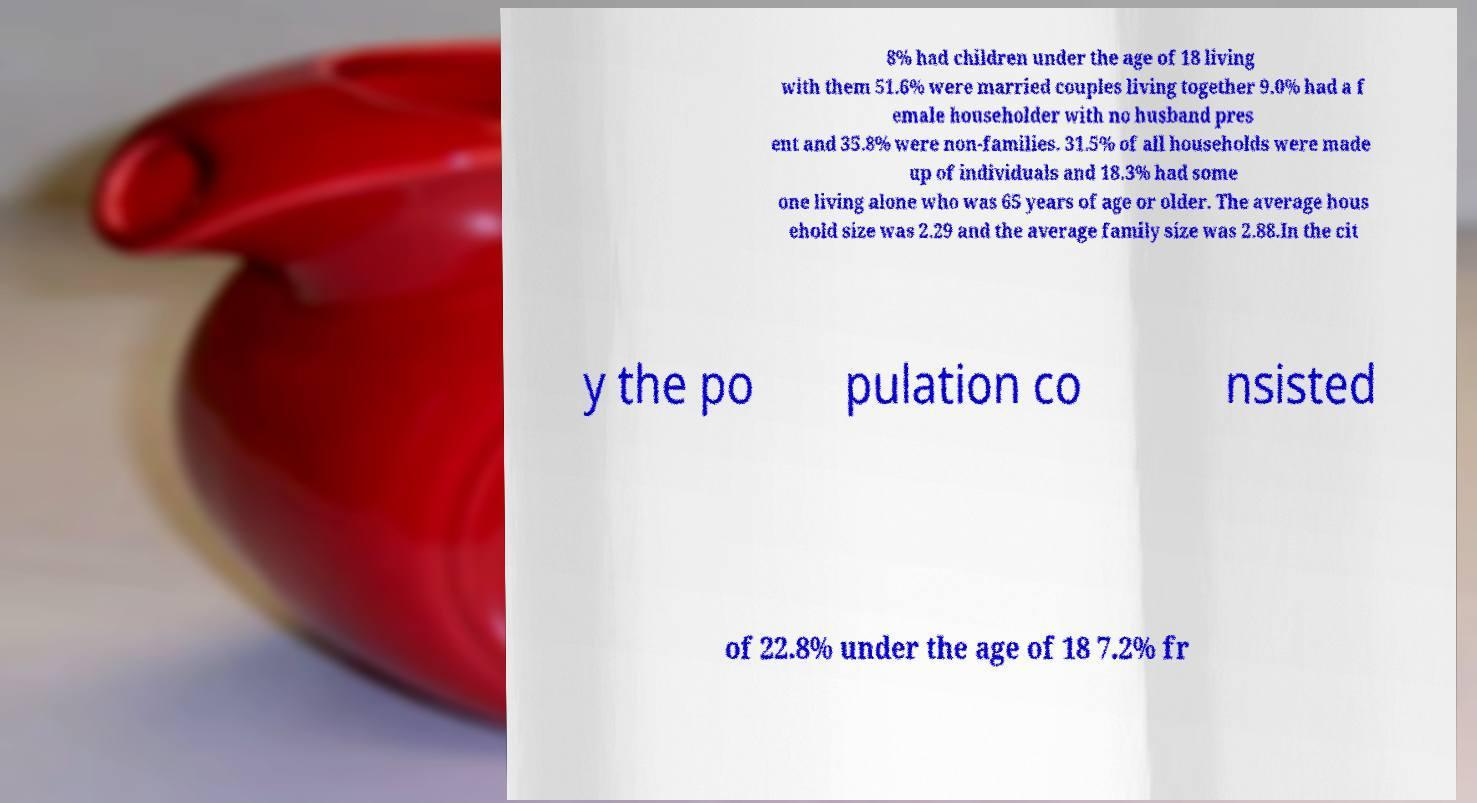Can you read and provide the text displayed in the image?This photo seems to have some interesting text. Can you extract and type it out for me? 8% had children under the age of 18 living with them 51.6% were married couples living together 9.0% had a f emale householder with no husband pres ent and 35.8% were non-families. 31.5% of all households were made up of individuals and 18.3% had some one living alone who was 65 years of age or older. The average hous ehold size was 2.29 and the average family size was 2.88.In the cit y the po pulation co nsisted of 22.8% under the age of 18 7.2% fr 